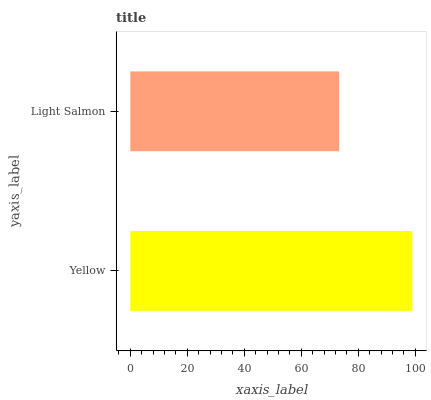Is Light Salmon the minimum?
Answer yes or no. Yes. Is Yellow the maximum?
Answer yes or no. Yes. Is Light Salmon the maximum?
Answer yes or no. No. Is Yellow greater than Light Salmon?
Answer yes or no. Yes. Is Light Salmon less than Yellow?
Answer yes or no. Yes. Is Light Salmon greater than Yellow?
Answer yes or no. No. Is Yellow less than Light Salmon?
Answer yes or no. No. Is Yellow the high median?
Answer yes or no. Yes. Is Light Salmon the low median?
Answer yes or no. Yes. Is Light Salmon the high median?
Answer yes or no. No. Is Yellow the low median?
Answer yes or no. No. 